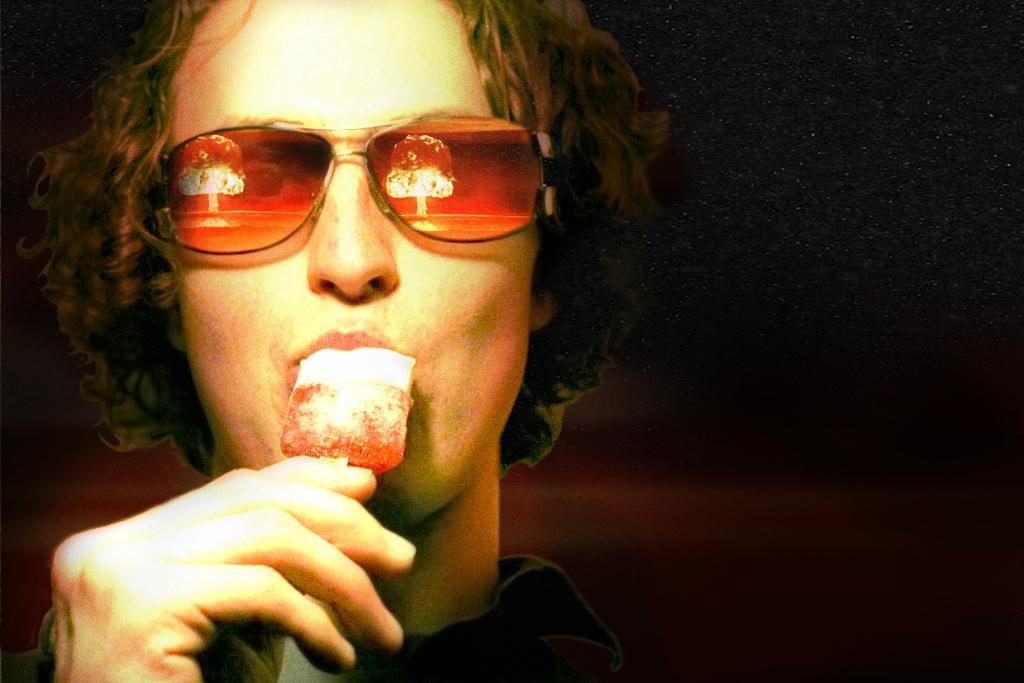What is the main subject of the image? There is a person in the image. What is the person holding in the image? The person is holding an ice cream. What is the person doing with the ice cream? The person is eating the ice cream. What can be observed about the background of the image? The background of the image is dark. What type of yoke is being used to carry the ice cream in the image? There is no yoke present in the image; the person is simply holding the ice cream. How does the bun affect the taste of the ice cream in the image? There is no bun mentioned in the image; the person is eating the ice cream directly. 